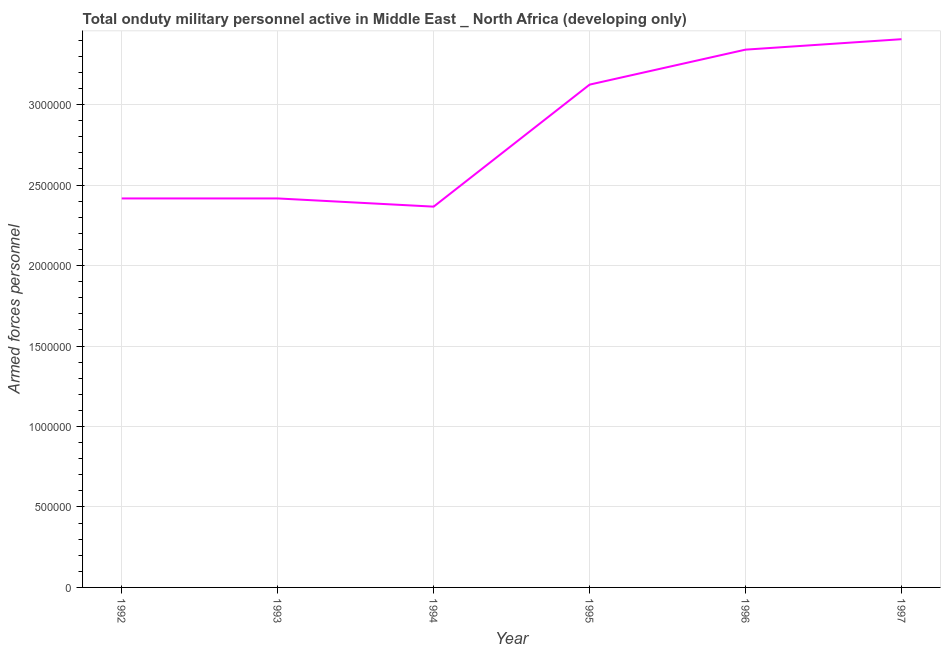What is the number of armed forces personnel in 1997?
Your response must be concise. 3.41e+06. Across all years, what is the maximum number of armed forces personnel?
Your response must be concise. 3.41e+06. Across all years, what is the minimum number of armed forces personnel?
Your answer should be compact. 2.37e+06. What is the sum of the number of armed forces personnel?
Your answer should be compact. 1.71e+07. What is the difference between the number of armed forces personnel in 1994 and 1996?
Provide a succinct answer. -9.76e+05. What is the average number of armed forces personnel per year?
Offer a terse response. 2.85e+06. What is the median number of armed forces personnel?
Offer a terse response. 2.77e+06. In how many years, is the number of armed forces personnel greater than 100000 ?
Offer a terse response. 6. Do a majority of the years between 1996 and 1993 (inclusive) have number of armed forces personnel greater than 1800000 ?
Offer a very short reply. Yes. What is the ratio of the number of armed forces personnel in 1992 to that in 1995?
Offer a very short reply. 0.77. Is the number of armed forces personnel in 1993 less than that in 1995?
Provide a succinct answer. Yes. Is the difference between the number of armed forces personnel in 1995 and 1997 greater than the difference between any two years?
Your response must be concise. No. What is the difference between the highest and the second highest number of armed forces personnel?
Give a very brief answer. 6.48e+04. What is the difference between the highest and the lowest number of armed forces personnel?
Offer a terse response. 1.04e+06. Does the number of armed forces personnel monotonically increase over the years?
Offer a very short reply. No. What is the difference between two consecutive major ticks on the Y-axis?
Your response must be concise. 5.00e+05. Are the values on the major ticks of Y-axis written in scientific E-notation?
Provide a short and direct response. No. Does the graph contain any zero values?
Provide a succinct answer. No. Does the graph contain grids?
Provide a short and direct response. Yes. What is the title of the graph?
Your answer should be compact. Total onduty military personnel active in Middle East _ North Africa (developing only). What is the label or title of the Y-axis?
Your response must be concise. Armed forces personnel. What is the Armed forces personnel in 1992?
Ensure brevity in your answer.  2.42e+06. What is the Armed forces personnel in 1993?
Give a very brief answer. 2.42e+06. What is the Armed forces personnel in 1994?
Keep it short and to the point. 2.37e+06. What is the Armed forces personnel in 1995?
Provide a short and direct response. 3.12e+06. What is the Armed forces personnel of 1996?
Give a very brief answer. 3.34e+06. What is the Armed forces personnel in 1997?
Provide a short and direct response. 3.41e+06. What is the difference between the Armed forces personnel in 1992 and 1994?
Your response must be concise. 5.10e+04. What is the difference between the Armed forces personnel in 1992 and 1995?
Offer a very short reply. -7.07e+05. What is the difference between the Armed forces personnel in 1992 and 1996?
Give a very brief answer. -9.25e+05. What is the difference between the Armed forces personnel in 1992 and 1997?
Your answer should be very brief. -9.89e+05. What is the difference between the Armed forces personnel in 1993 and 1994?
Ensure brevity in your answer.  5.10e+04. What is the difference between the Armed forces personnel in 1993 and 1995?
Offer a very short reply. -7.07e+05. What is the difference between the Armed forces personnel in 1993 and 1996?
Offer a terse response. -9.25e+05. What is the difference between the Armed forces personnel in 1993 and 1997?
Offer a terse response. -9.89e+05. What is the difference between the Armed forces personnel in 1994 and 1995?
Your answer should be very brief. -7.58e+05. What is the difference between the Armed forces personnel in 1994 and 1996?
Your answer should be compact. -9.76e+05. What is the difference between the Armed forces personnel in 1994 and 1997?
Provide a succinct answer. -1.04e+06. What is the difference between the Armed forces personnel in 1995 and 1996?
Offer a terse response. -2.17e+05. What is the difference between the Armed forces personnel in 1995 and 1997?
Provide a succinct answer. -2.82e+05. What is the difference between the Armed forces personnel in 1996 and 1997?
Make the answer very short. -6.48e+04. What is the ratio of the Armed forces personnel in 1992 to that in 1993?
Provide a succinct answer. 1. What is the ratio of the Armed forces personnel in 1992 to that in 1994?
Provide a short and direct response. 1.02. What is the ratio of the Armed forces personnel in 1992 to that in 1995?
Make the answer very short. 0.77. What is the ratio of the Armed forces personnel in 1992 to that in 1996?
Your answer should be compact. 0.72. What is the ratio of the Armed forces personnel in 1992 to that in 1997?
Make the answer very short. 0.71. What is the ratio of the Armed forces personnel in 1993 to that in 1995?
Your response must be concise. 0.77. What is the ratio of the Armed forces personnel in 1993 to that in 1996?
Your answer should be very brief. 0.72. What is the ratio of the Armed forces personnel in 1993 to that in 1997?
Make the answer very short. 0.71. What is the ratio of the Armed forces personnel in 1994 to that in 1995?
Your answer should be very brief. 0.76. What is the ratio of the Armed forces personnel in 1994 to that in 1996?
Provide a succinct answer. 0.71. What is the ratio of the Armed forces personnel in 1994 to that in 1997?
Provide a short and direct response. 0.69. What is the ratio of the Armed forces personnel in 1995 to that in 1996?
Offer a terse response. 0.94. What is the ratio of the Armed forces personnel in 1995 to that in 1997?
Your response must be concise. 0.92. 